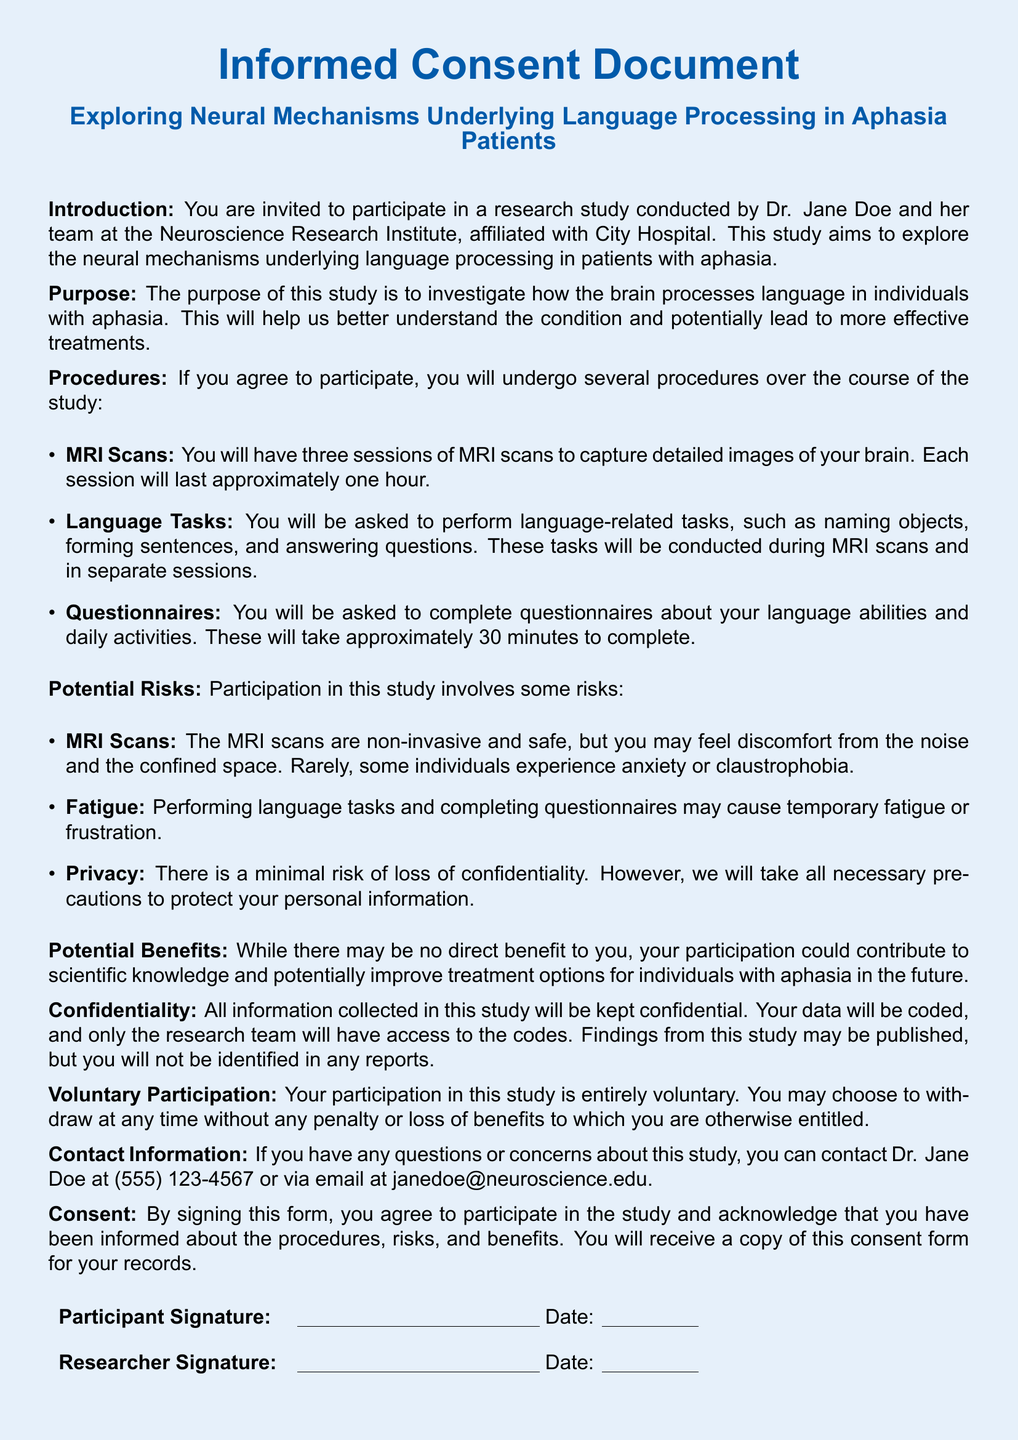What is the name of the principal investigator? The principal investigator is mentioned in the introduction section of the document.
Answer: Dr. Jane Doe How many MRI sessions will participants undergo? The procedures section states the number of MRI sessions planned for participants.
Answer: Three sessions What types of tasks will participants perform? The procedures section describes the types of tasks participants will engage in during the study.
Answer: Language-related tasks What is a potential risk mentioned for MRI scans? The potential risks listed indicate specific risks participants may experience during MRI scans.
Answer: Anxiety What is the duration of the questionnaire completion? The procedures section states how long it will take for participants to complete the questionnaires.
Answer: Approximately 30 minutes Is participation voluntary? The document explicitly states the nature of participation in the study.
Answer: Yes What might participants experience during language tasks? The document lists possible effects while participants perform specific tasks in the study.
Answer: Temporary fatigue What will happen to the collected information? The confidentiality section describes how the collected data will be treated.
Answer: Kept confidential 